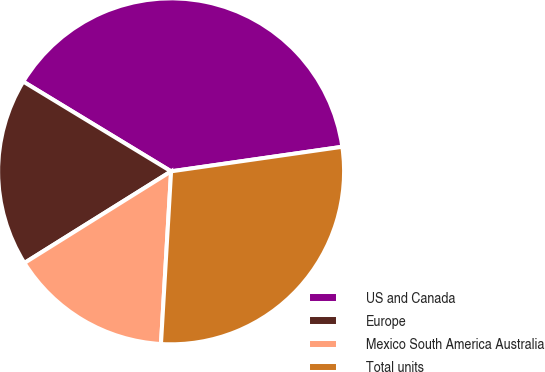<chart> <loc_0><loc_0><loc_500><loc_500><pie_chart><fcel>US and Canada<fcel>Europe<fcel>Mexico South America Australia<fcel>Total units<nl><fcel>39.05%<fcel>17.57%<fcel>15.18%<fcel>28.2%<nl></chart> 